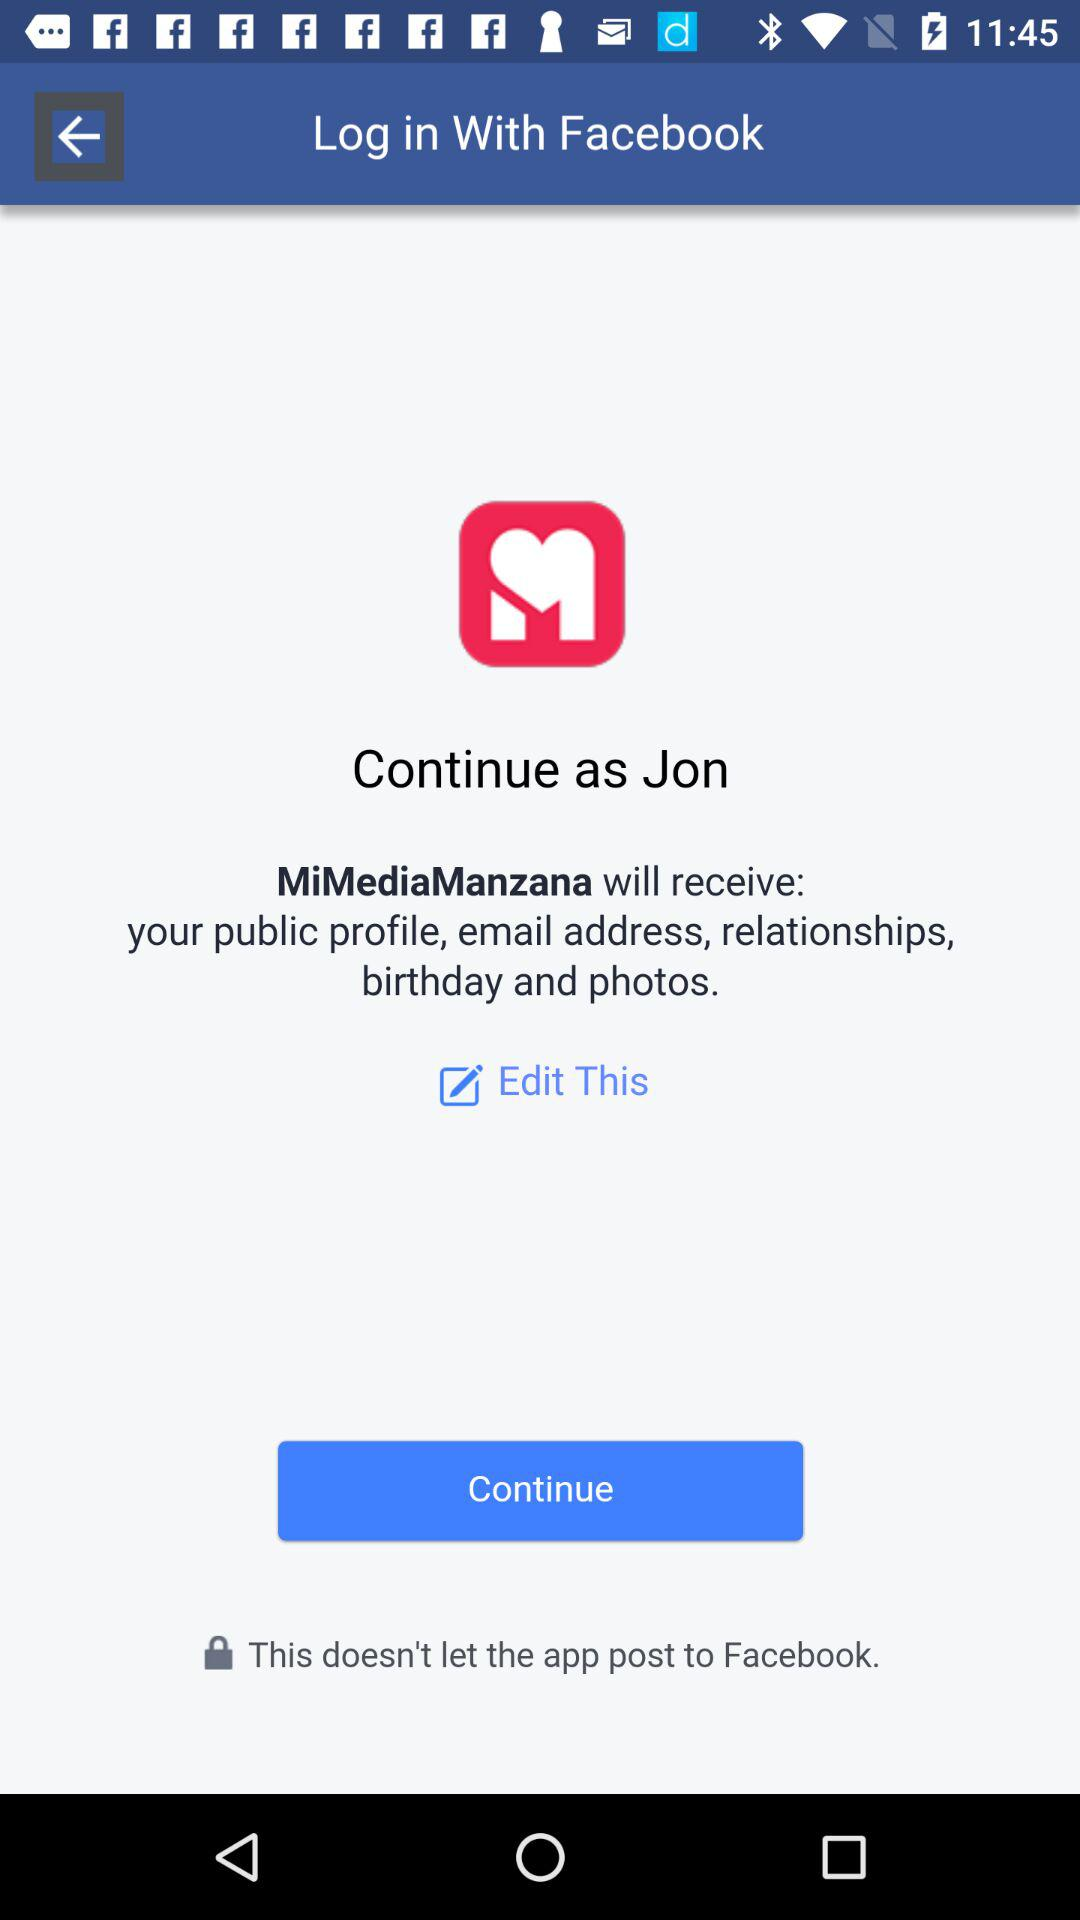What is the user name to continue the profile? The user name is Jon. 